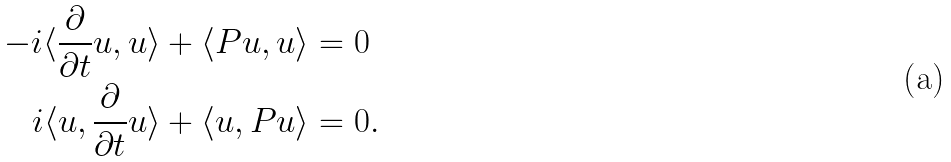<formula> <loc_0><loc_0><loc_500><loc_500>- i \langle \frac { \partial } { \partial t } u , u \rangle + \langle P u , u \rangle & = 0 \\ i \langle u , \frac { \partial } { \partial t } u \rangle + \langle u , P u \rangle & = 0 .</formula> 